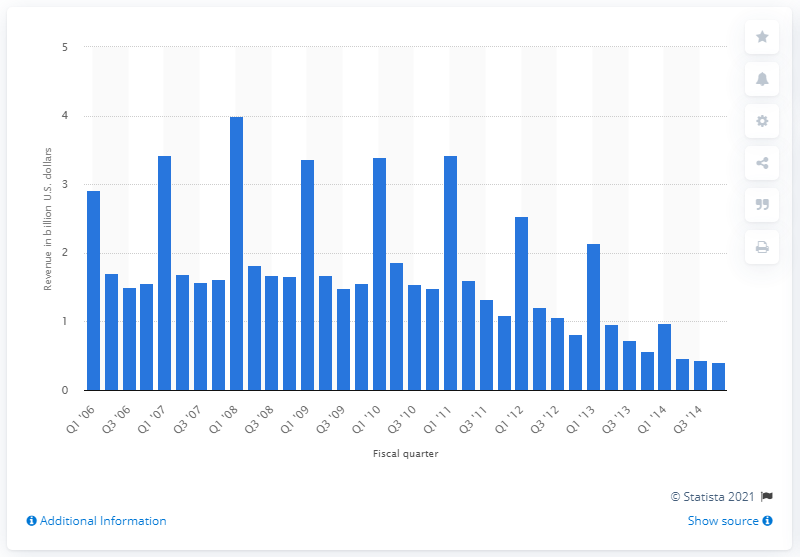List a handful of essential elements in this visual. In the first quarter of 2014, the revenue of the iPod was 0.97 million. 